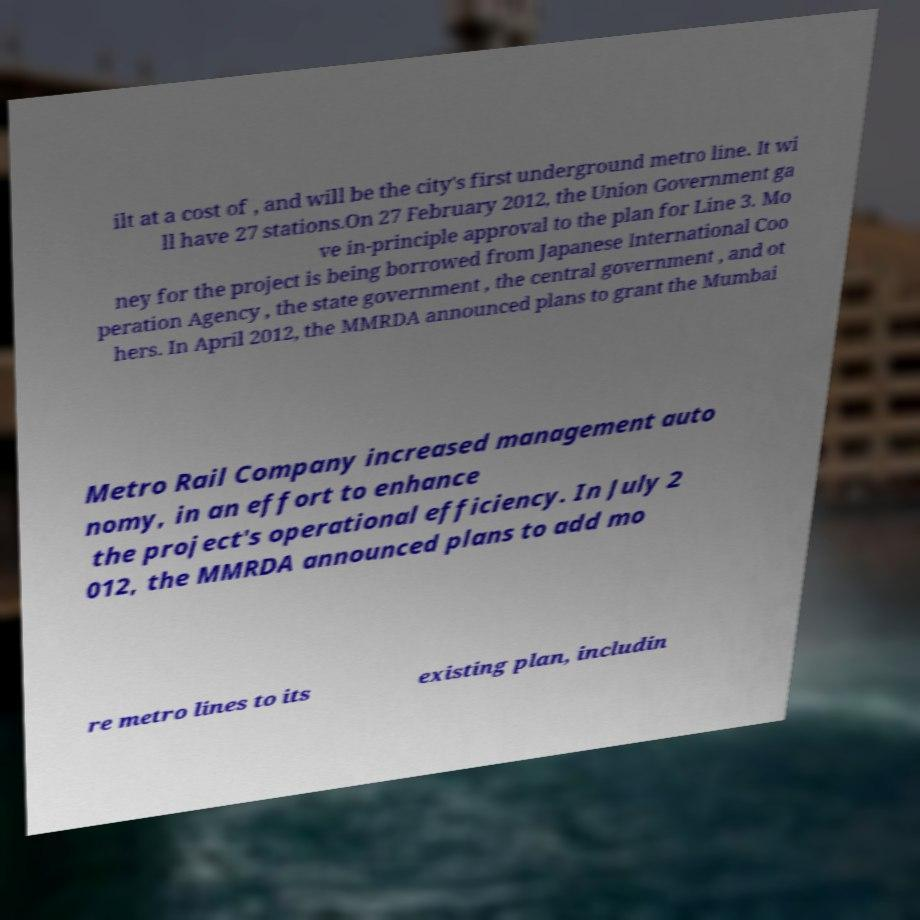What messages or text are displayed in this image? I need them in a readable, typed format. ilt at a cost of , and will be the city's first underground metro line. It wi ll have 27 stations.On 27 February 2012, the Union Government ga ve in-principle approval to the plan for Line 3. Mo ney for the project is being borrowed from Japanese International Coo peration Agency , the state government , the central government , and ot hers. In April 2012, the MMRDA announced plans to grant the Mumbai Metro Rail Company increased management auto nomy, in an effort to enhance the project's operational efficiency. In July 2 012, the MMRDA announced plans to add mo re metro lines to its existing plan, includin 